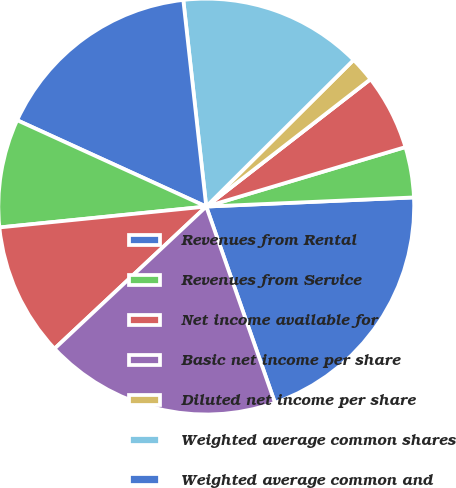Convert chart to OTSL. <chart><loc_0><loc_0><loc_500><loc_500><pie_chart><fcel>Revenues from Rental<fcel>Revenues from Service<fcel>Net income available for<fcel>Basic net income per share<fcel>Diluted net income per share<fcel>Weighted average common shares<fcel>Weighted average common and<fcel>Funds From Operations (1)<fcel>Operating activities<fcel>Investing activities<nl><fcel>20.34%<fcel>3.92%<fcel>5.88%<fcel>0.0%<fcel>1.96%<fcel>14.3%<fcel>16.42%<fcel>8.42%<fcel>10.38%<fcel>18.38%<nl></chart> 